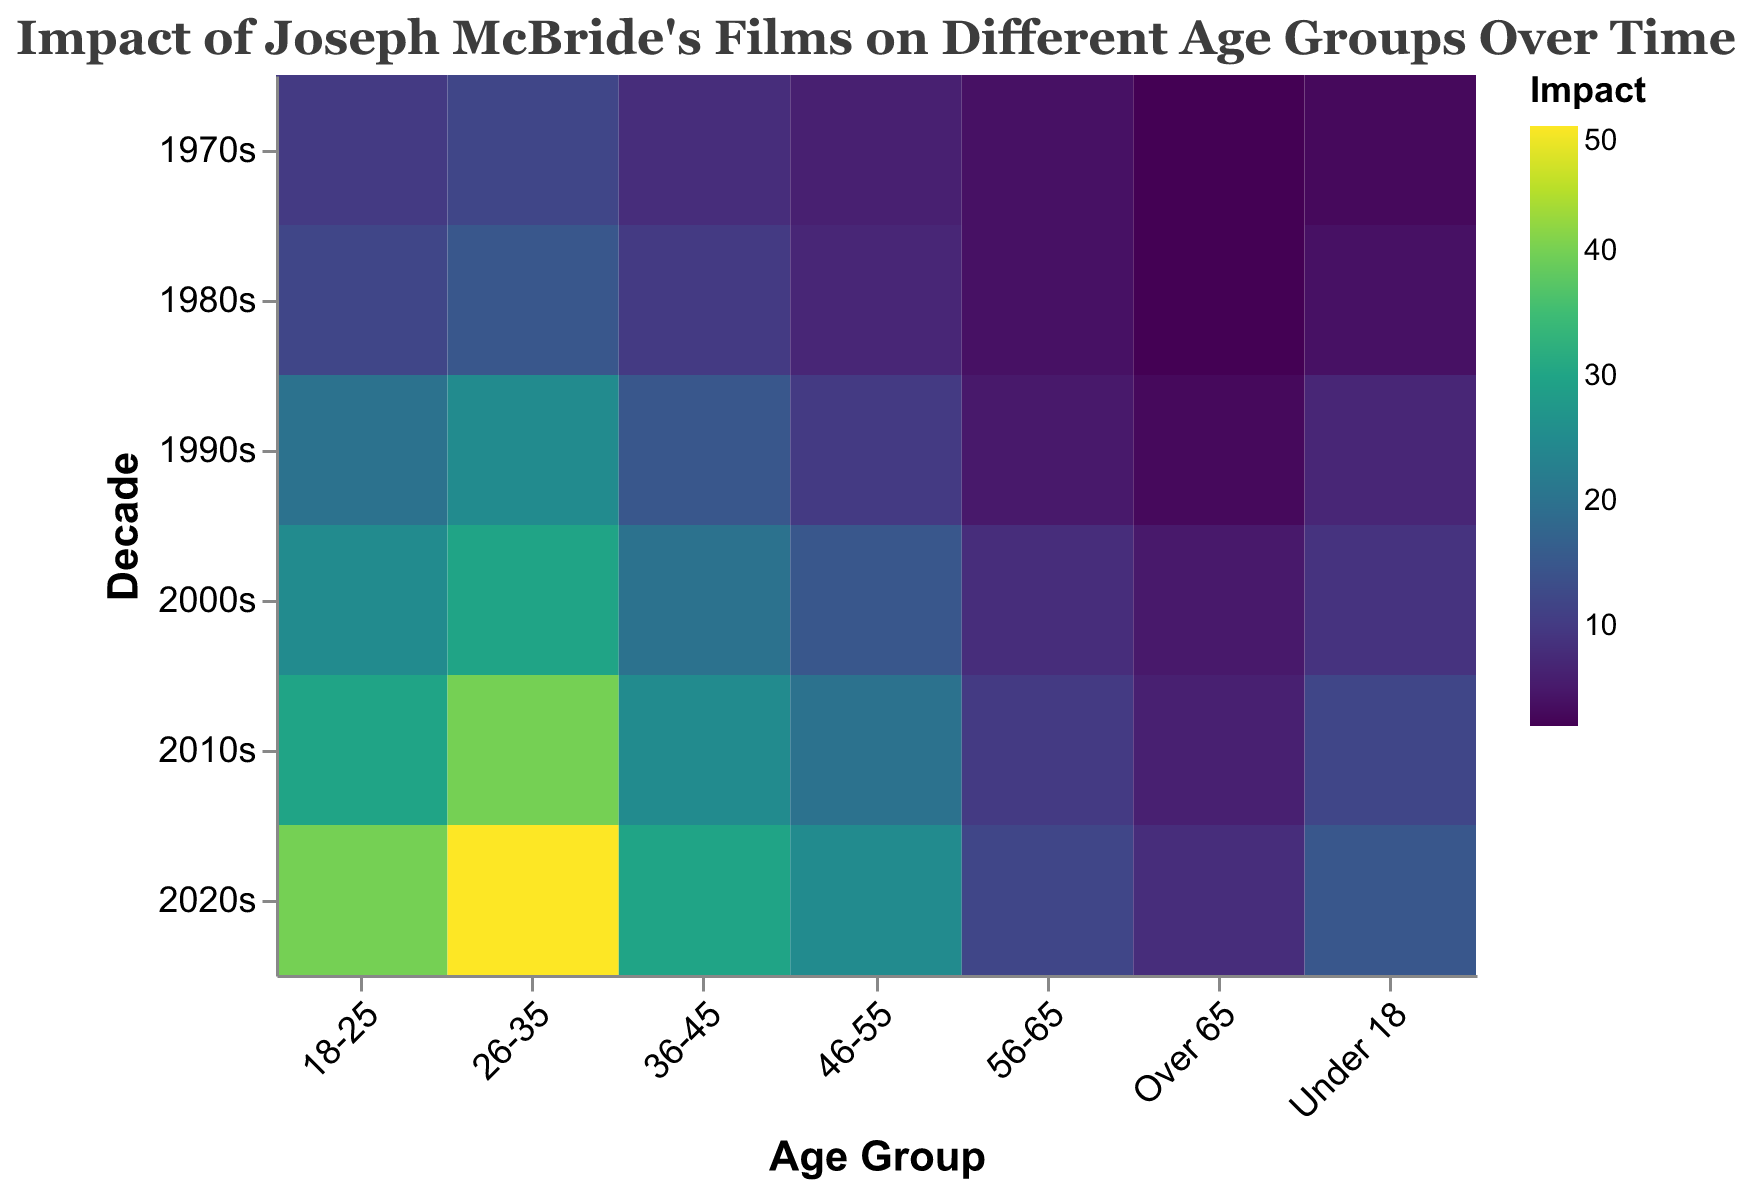What is the title of the heatmap? The title is located at the top of the heatmap and reads "Impact of Joseph McBride's Films on Different Age Groups Over Time".
Answer: Impact of Joseph McBride's Films on Different Age Groups Over Time What is the color scheme used in the heatmap? Observing the heatmap, you can see the color gradient varies from light to dark, which is specified as the "viridis" color scheme in the code.
Answer: viridis Which age group had the highest impact from Joseph McBride's films in the 2010s? Looking at the color intensity in the column for the 2010s, the age group "26-35" has the darkest color, which corresponds to the highest impact value.
Answer: 26-35 What's the impact difference of Joseph McBride's films on the 'Under 18' age group between the 1970s and 2020s? In the column for "Under 18", find the values for the 1970s and 2020s which are 3 and 15 respectively. Subtracting these values, 15 - 3 gives the impact difference.
Answer: 12 Which decade showed the highest increase in impact for the age group '18-25'? Reviewing the "18-25" row, observe the progression of impact scores by decade. The increase is highest from the 2010s to the 2020s, going from 30 to 40.
Answer: 2010s to 2020s Compare the impact in the 1980s between age groups '36-45' and '46-55'. Which group had a higher impact? Look at the values in the 1980s column for both age groups: '36-45' has 10 and '46-55' has 7. Comparing these, '36-45' had a higher impact.
Answer: 36-45 What is the median impact value for age group '26-35' across all decades? List the values for '26-35' across decades: 12, 15, 25, 30, 40, 50. The median is the average of the middle two values (25 and 30), so (25 + 30) / 2 = 27.5.
Answer: 27.5 Which age group had the least impact from Joseph McBride's films in the 2000s? In the column for the 2000s, the "Over 65" group has the lightest color and the lowest value which is 5.
Answer: Over 65 What is the average impact of Joseph McBride's films on the '56-65' age group over all decades? Add the values for '56-65' across the decades (4 + 4 + 5 + 8 + 10 + 12) which equals 43. Divide by the number of values (6) to get the average: 43 / 6 ≈ 7.17.
Answer: 7.17 Which decade had the highest overall impact across all age groups? Sum the values in each decade column: 1970s (45), 1980s (54), 1990s (85), 2000s (112), 2010s (143), 2020s (180). The 2020s have the highest sum indicating the highest overall impact.
Answer: 2020s 